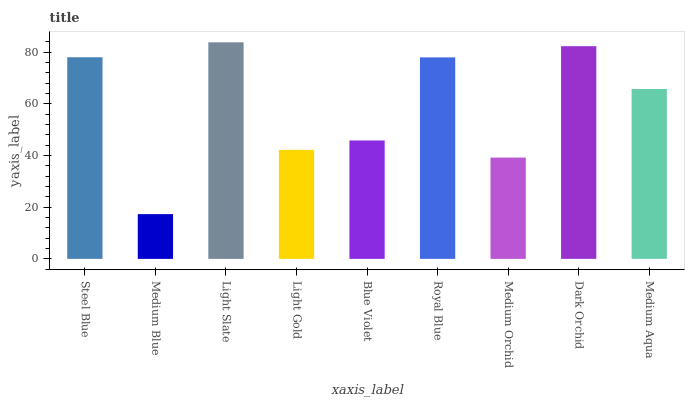Is Medium Blue the minimum?
Answer yes or no. Yes. Is Light Slate the maximum?
Answer yes or no. Yes. Is Light Slate the minimum?
Answer yes or no. No. Is Medium Blue the maximum?
Answer yes or no. No. Is Light Slate greater than Medium Blue?
Answer yes or no. Yes. Is Medium Blue less than Light Slate?
Answer yes or no. Yes. Is Medium Blue greater than Light Slate?
Answer yes or no. No. Is Light Slate less than Medium Blue?
Answer yes or no. No. Is Medium Aqua the high median?
Answer yes or no. Yes. Is Medium Aqua the low median?
Answer yes or no. Yes. Is Royal Blue the high median?
Answer yes or no. No. Is Steel Blue the low median?
Answer yes or no. No. 